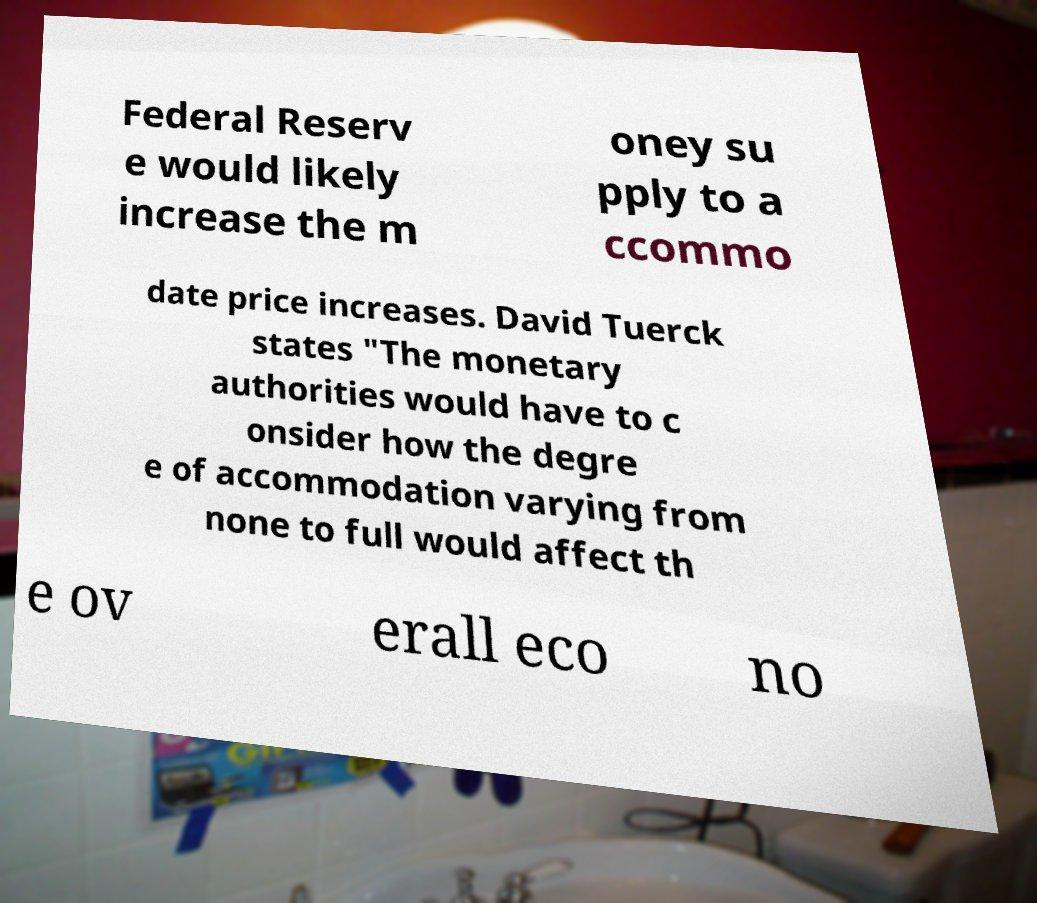Please read and relay the text visible in this image. What does it say? Federal Reserv e would likely increase the m oney su pply to a ccommo date price increases. David Tuerck states "The monetary authorities would have to c onsider how the degre e of accommodation varying from none to full would affect th e ov erall eco no 